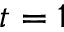Convert formula to latex. <formula><loc_0><loc_0><loc_500><loc_500>t = 1</formula> 